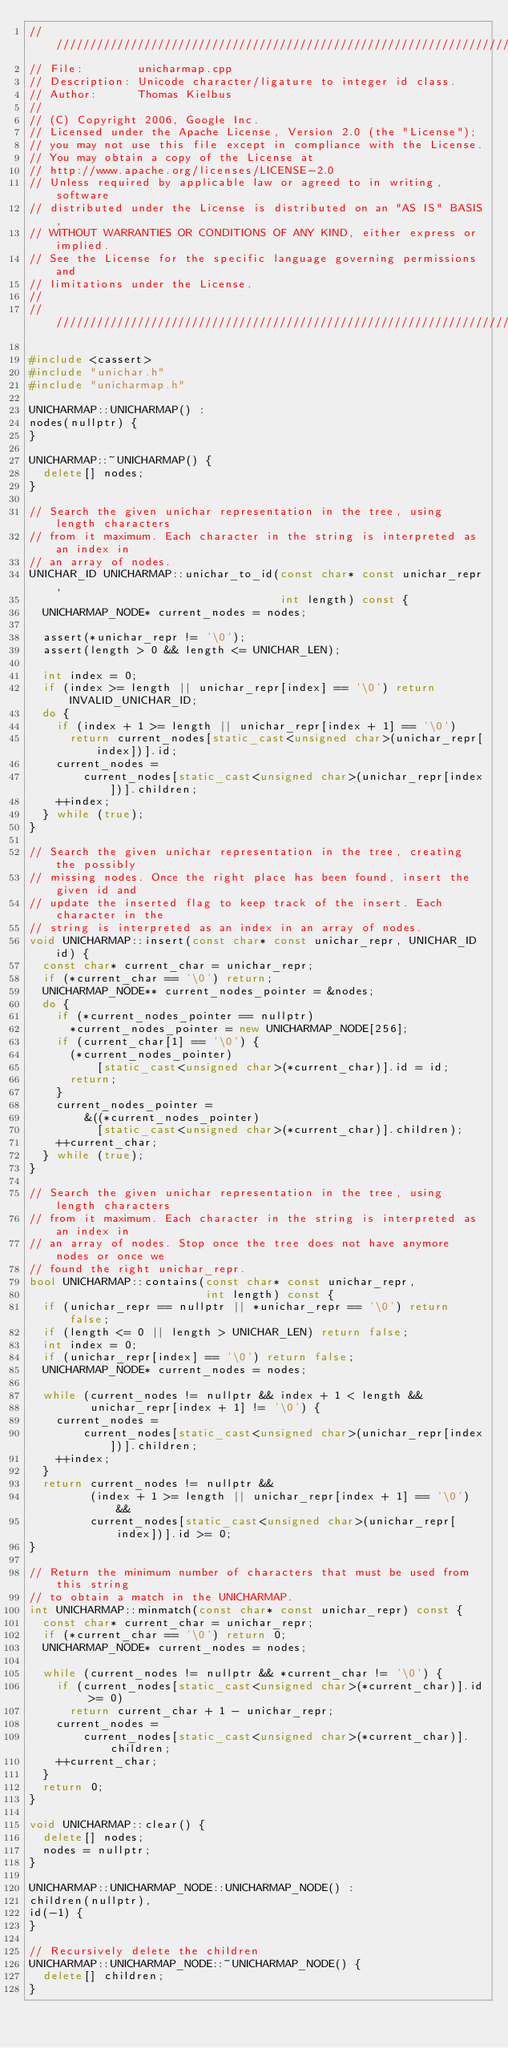<code> <loc_0><loc_0><loc_500><loc_500><_C++_>///////////////////////////////////////////////////////////////////////
// File:        unicharmap.cpp
// Description: Unicode character/ligature to integer id class.
// Author:      Thomas Kielbus
//
// (C) Copyright 2006, Google Inc.
// Licensed under the Apache License, Version 2.0 (the "License");
// you may not use this file except in compliance with the License.
// You may obtain a copy of the License at
// http://www.apache.org/licenses/LICENSE-2.0
// Unless required by applicable law or agreed to in writing, software
// distributed under the License is distributed on an "AS IS" BASIS,
// WITHOUT WARRANTIES OR CONDITIONS OF ANY KIND, either express or implied.
// See the License for the specific language governing permissions and
// limitations under the License.
//
///////////////////////////////////////////////////////////////////////

#include <cassert>
#include "unichar.h"
#include "unicharmap.h"

UNICHARMAP::UNICHARMAP() :
nodes(nullptr) {
}

UNICHARMAP::~UNICHARMAP() {
  delete[] nodes;
}

// Search the given unichar representation in the tree, using length characters
// from it maximum. Each character in the string is interpreted as an index in
// an array of nodes.
UNICHAR_ID UNICHARMAP::unichar_to_id(const char* const unichar_repr,
                                     int length) const {
  UNICHARMAP_NODE* current_nodes = nodes;

  assert(*unichar_repr != '\0');
  assert(length > 0 && length <= UNICHAR_LEN);

  int index = 0;
  if (index >= length || unichar_repr[index] == '\0') return INVALID_UNICHAR_ID;
  do {
    if (index + 1 >= length || unichar_repr[index + 1] == '\0')
      return current_nodes[static_cast<unsigned char>(unichar_repr[index])].id;
    current_nodes =
        current_nodes[static_cast<unsigned char>(unichar_repr[index])].children;
    ++index;
  } while (true);
}

// Search the given unichar representation in the tree, creating the possibly
// missing nodes. Once the right place has been found, insert the given id and
// update the inserted flag to keep track of the insert. Each character in the
// string is interpreted as an index in an array of nodes.
void UNICHARMAP::insert(const char* const unichar_repr, UNICHAR_ID id) {
  const char* current_char = unichar_repr;
  if (*current_char == '\0') return;
  UNICHARMAP_NODE** current_nodes_pointer = &nodes;
  do {
    if (*current_nodes_pointer == nullptr)
      *current_nodes_pointer = new UNICHARMAP_NODE[256];
    if (current_char[1] == '\0') {
      (*current_nodes_pointer)
          [static_cast<unsigned char>(*current_char)].id = id;
      return;
    }
    current_nodes_pointer =
        &((*current_nodes_pointer)
          [static_cast<unsigned char>(*current_char)].children);
    ++current_char;
  } while (true);
}

// Search the given unichar representation in the tree, using length characters
// from it maximum. Each character in the string is interpreted as an index in
// an array of nodes. Stop once the tree does not have anymore nodes or once we
// found the right unichar_repr.
bool UNICHARMAP::contains(const char* const unichar_repr,
                          int length) const {
  if (unichar_repr == nullptr || *unichar_repr == '\0') return false;
  if (length <= 0 || length > UNICHAR_LEN) return false;
  int index = 0;
  if (unichar_repr[index] == '\0') return false;
  UNICHARMAP_NODE* current_nodes = nodes;

  while (current_nodes != nullptr && index + 1 < length &&
         unichar_repr[index + 1] != '\0') {
    current_nodes =
        current_nodes[static_cast<unsigned char>(unichar_repr[index])].children;
    ++index;
  }
  return current_nodes != nullptr &&
         (index + 1 >= length || unichar_repr[index + 1] == '\0') &&
         current_nodes[static_cast<unsigned char>(unichar_repr[index])].id >= 0;
}

// Return the minimum number of characters that must be used from this string
// to obtain a match in the UNICHARMAP.
int UNICHARMAP::minmatch(const char* const unichar_repr) const {
  const char* current_char = unichar_repr;
  if (*current_char == '\0') return 0;
  UNICHARMAP_NODE* current_nodes = nodes;

  while (current_nodes != nullptr && *current_char != '\0') {
    if (current_nodes[static_cast<unsigned char>(*current_char)].id >= 0)
      return current_char + 1 - unichar_repr;
    current_nodes =
        current_nodes[static_cast<unsigned char>(*current_char)].children;
    ++current_char;
  }
  return 0;
}

void UNICHARMAP::clear() {
  delete[] nodes;
  nodes = nullptr;
}

UNICHARMAP::UNICHARMAP_NODE::UNICHARMAP_NODE() :
children(nullptr),
id(-1) {
}

// Recursively delete the children
UNICHARMAP::UNICHARMAP_NODE::~UNICHARMAP_NODE() {
  delete[] children;
}
</code> 